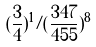Convert formula to latex. <formula><loc_0><loc_0><loc_500><loc_500>( \frac { 3 } { 4 } ) ^ { 1 } / ( \frac { 3 4 7 } { 4 5 5 } ) ^ { 8 }</formula> 